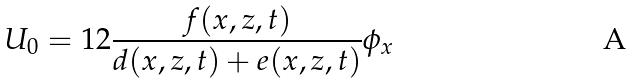<formula> <loc_0><loc_0><loc_500><loc_500>U _ { 0 } = 1 2 \frac { f ( x , z , t ) } { d ( x , z , t ) + e ( x , z , t ) } \phi _ { x }</formula> 